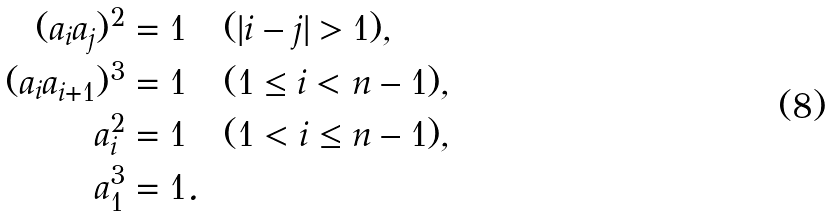<formula> <loc_0><loc_0><loc_500><loc_500>( a _ { i } a _ { j } ) ^ { 2 } = 1 & \quad ( | i - j | > 1 ) , \\ ( a _ { i } a _ { i + 1 } ) ^ { 3 } = 1 & \quad ( 1 \leq i < n - 1 ) , \\ a _ { i } ^ { 2 } = 1 & \quad ( 1 < i \leq n - 1 ) , \\ a _ { 1 } ^ { 3 } = 1 & .</formula> 